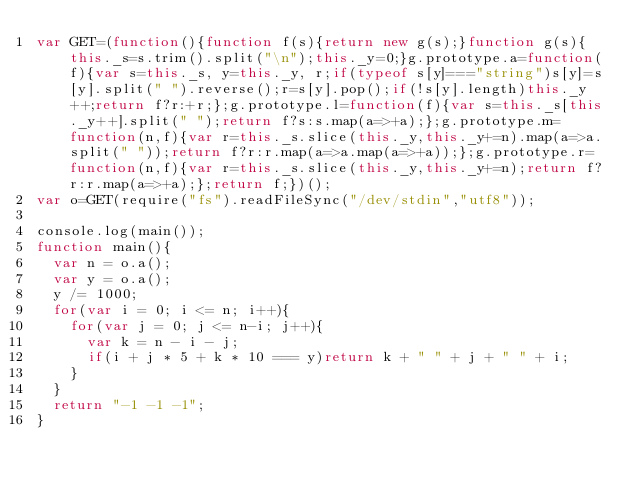Convert code to text. <code><loc_0><loc_0><loc_500><loc_500><_JavaScript_>var GET=(function(){function f(s){return new g(s);}function g(s){this._s=s.trim().split("\n");this._y=0;}g.prototype.a=function(f){var s=this._s, y=this._y, r;if(typeof s[y]==="string")s[y]=s[y].split(" ").reverse();r=s[y].pop();if(!s[y].length)this._y++;return f?r:+r;};g.prototype.l=function(f){var s=this._s[this._y++].split(" ");return f?s:s.map(a=>+a);};g.prototype.m=function(n,f){var r=this._s.slice(this._y,this._y+=n).map(a=>a.split(" "));return f?r:r.map(a=>a.map(a=>+a));};g.prototype.r=function(n,f){var r=this._s.slice(this._y,this._y+=n);return f?r:r.map(a=>+a);};return f;})();
var o=GET(require("fs").readFileSync("/dev/stdin","utf8"));

console.log(main());
function main(){
  var n = o.a();
  var y = o.a();
  y /= 1000;
  for(var i = 0; i <= n; i++){
    for(var j = 0; j <= n-i; j++){
      var k = n - i - j;
      if(i + j * 5 + k * 10 === y)return k + " " + j + " " + i;
    }
  }
  return "-1 -1 -1";
}</code> 